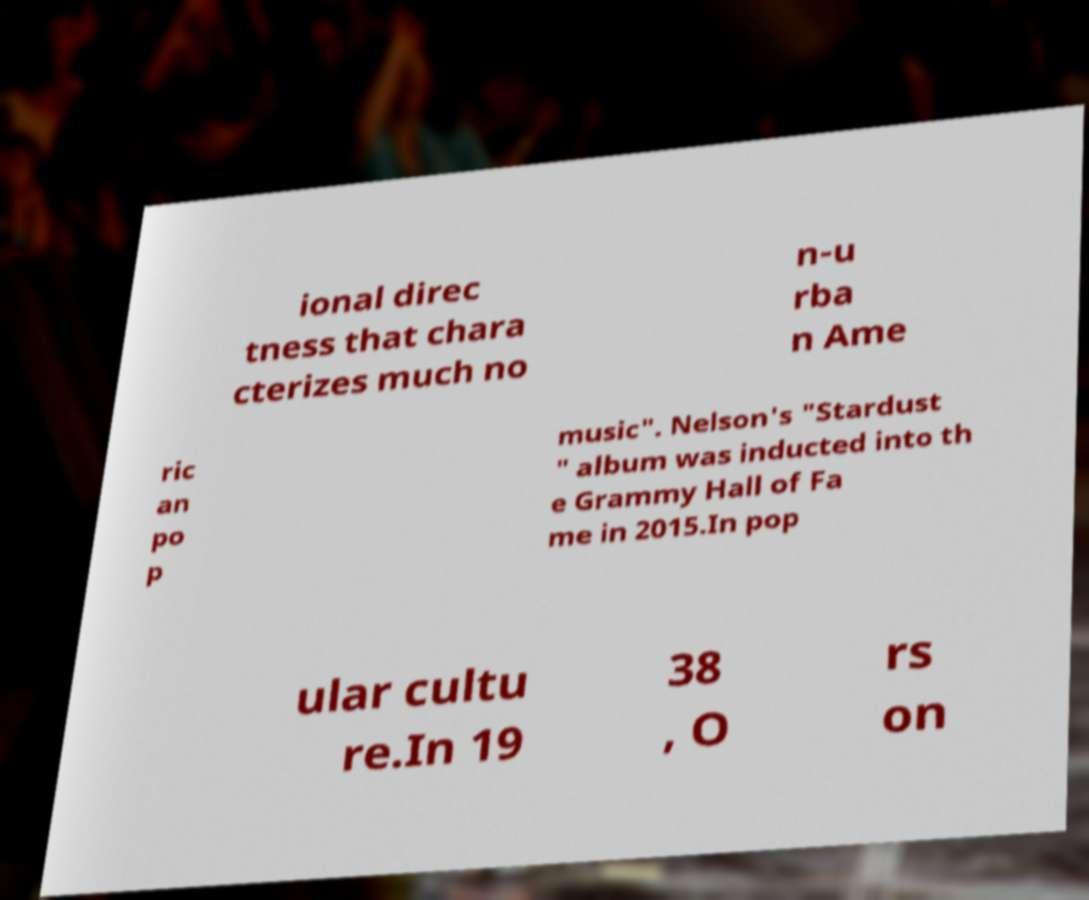Please read and relay the text visible in this image. What does it say? ional direc tness that chara cterizes much no n-u rba n Ame ric an po p music". Nelson's "Stardust " album was inducted into th e Grammy Hall of Fa me in 2015.In pop ular cultu re.In 19 38 , O rs on 